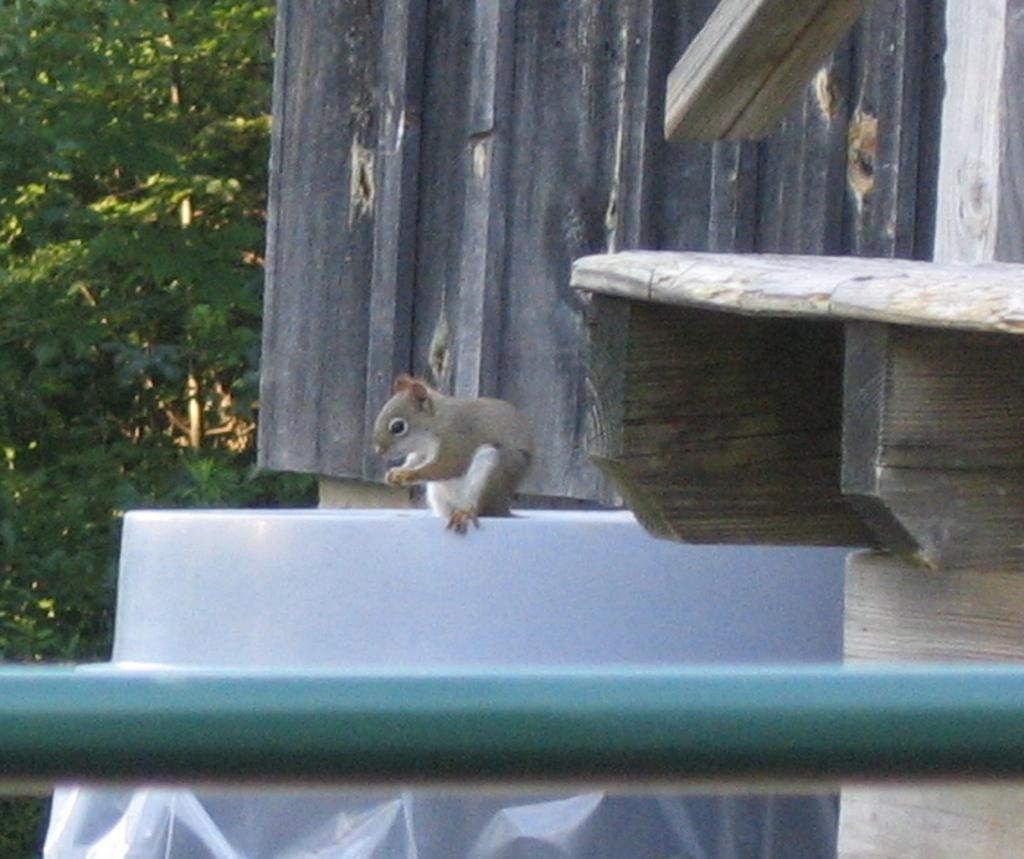What is depicted on the wall in the image? There is an animal depicted on the wall in the image. Can you describe the coloration of the animal? The animal has a white and brown coloration. What object is located in the front of the image? There is a rod in the front of the image. What can be seen in the background of the image? There are trees visible in the background of the image. How many rabbits are helping the fireman in the image? There are no rabbits or firemen present in the image; it features an animal on the wall and a rod in the front. What is the level of wealth depicted in the image? There is no indication of wealth in the image; it focuses on the animal, the rod, and the trees in the background. 